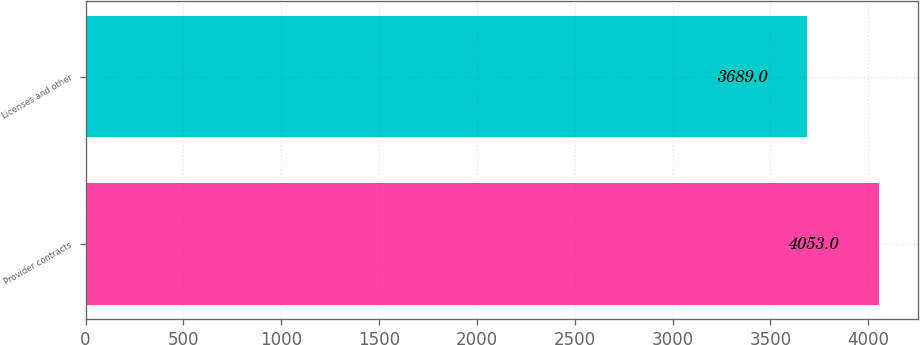<chart> <loc_0><loc_0><loc_500><loc_500><bar_chart><fcel>Provider contracts<fcel>Licenses and other<nl><fcel>4053<fcel>3689<nl></chart> 